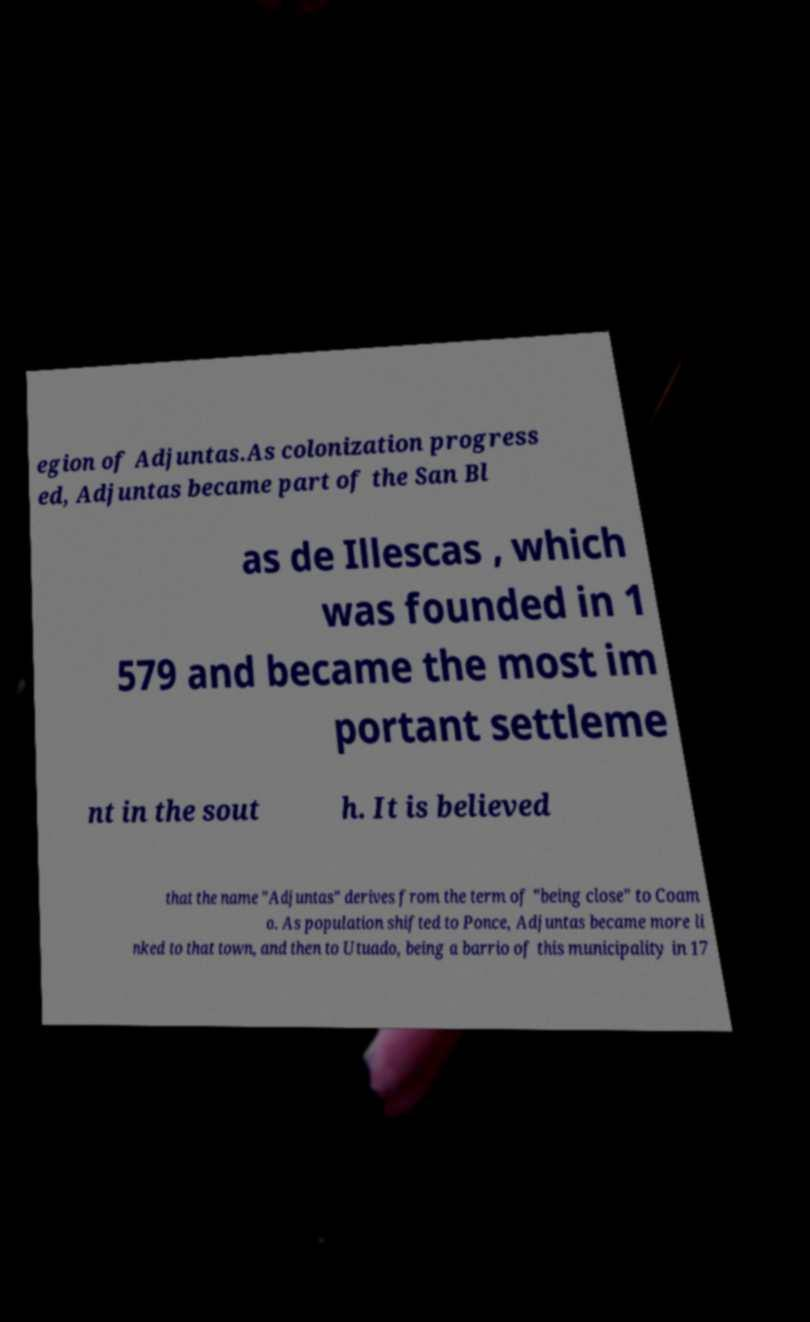Can you accurately transcribe the text from the provided image for me? egion of Adjuntas.As colonization progress ed, Adjuntas became part of the San Bl as de Illescas , which was founded in 1 579 and became the most im portant settleme nt in the sout h. It is believed that the name "Adjuntas" derives from the term of "being close" to Coam o. As population shifted to Ponce, Adjuntas became more li nked to that town, and then to Utuado, being a barrio of this municipality in 17 